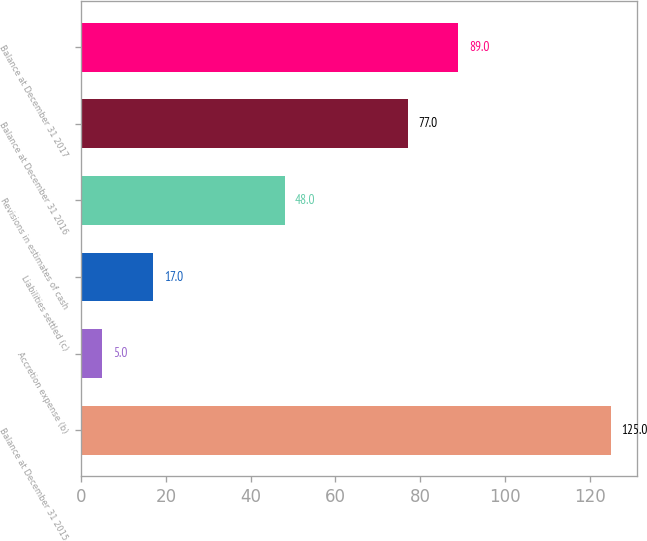<chart> <loc_0><loc_0><loc_500><loc_500><bar_chart><fcel>Balance at December 31 2015<fcel>Accretion expense (b)<fcel>Liabilities settled (c)<fcel>Revisions in estimates of cash<fcel>Balance at December 31 2016<fcel>Balance at December 31 2017<nl><fcel>125<fcel>5<fcel>17<fcel>48<fcel>77<fcel>89<nl></chart> 